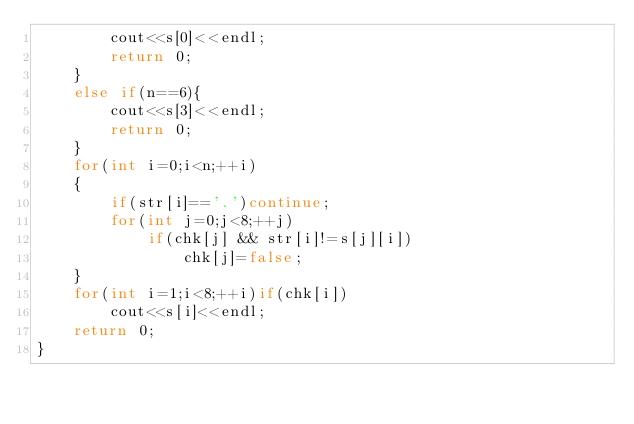<code> <loc_0><loc_0><loc_500><loc_500><_C++_>        cout<<s[0]<<endl;
        return 0;
    }
    else if(n==6){
        cout<<s[3]<<endl;
        return 0;
    }
    for(int i=0;i<n;++i)
    {
        if(str[i]=='.')continue;
        for(int j=0;j<8;++j)
            if(chk[j] && str[i]!=s[j][i])
                chk[j]=false;
    }
    for(int i=1;i<8;++i)if(chk[i])
        cout<<s[i]<<endl;
    return 0;
}</code> 